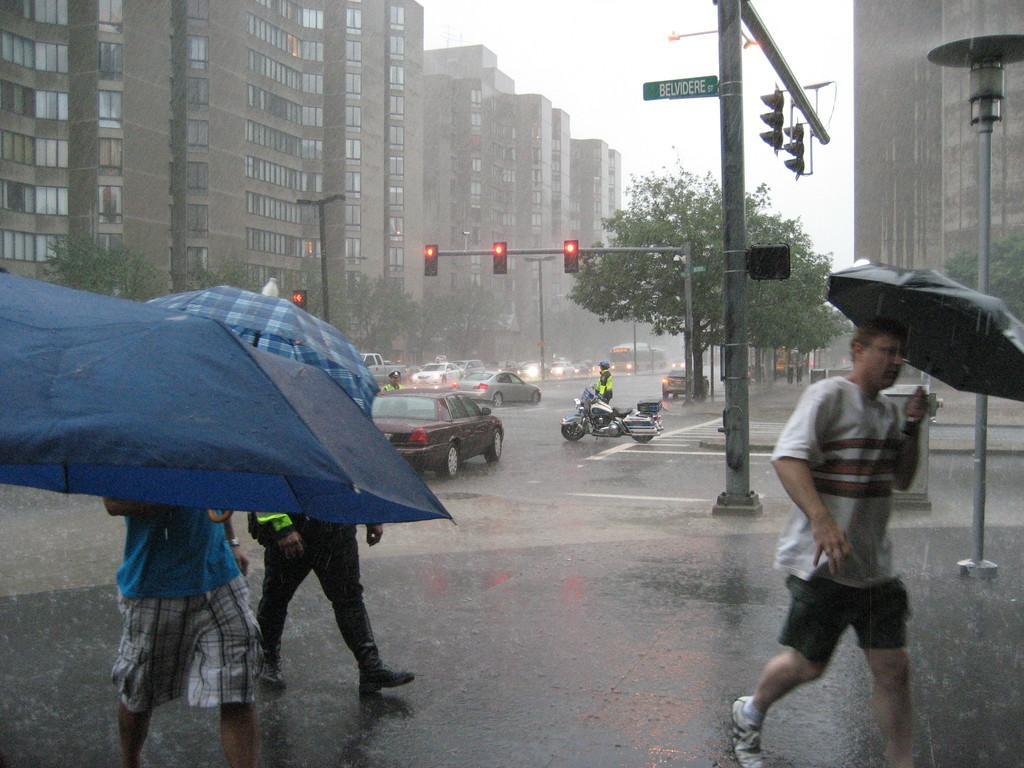Could you give a brief overview of what you see in this image? In this picture we can see it is raining. In the foreground of the picture there are people, many people are carrying umbrellas. At the bottom it is road. In the middle of the picture there are buildings, signal lights, street light, trees, vehicles, motorbike, people and various other object. At the top and in the background there is sky. 